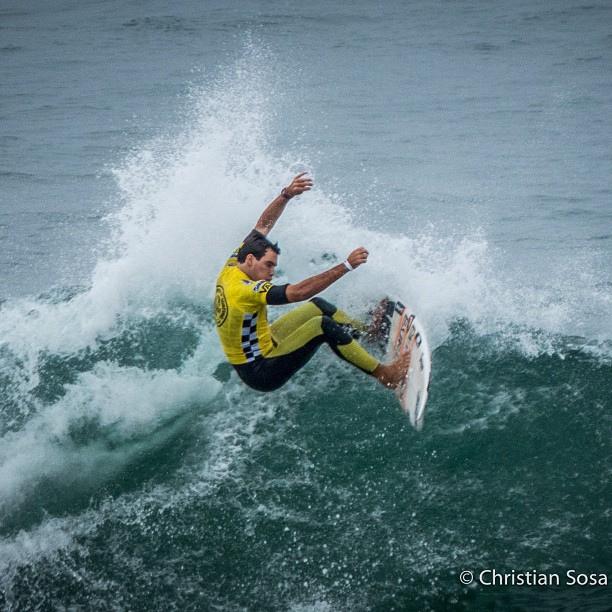Is the surfer competing?
Concise answer only. Yes. What colors make the checkerboard pattern on his shirt?
Give a very brief answer. Black and white. Does this surfer have anything on his wrist?
Answer briefly. Yes. What trick is this man performing?
Be succinct. Surfing. 